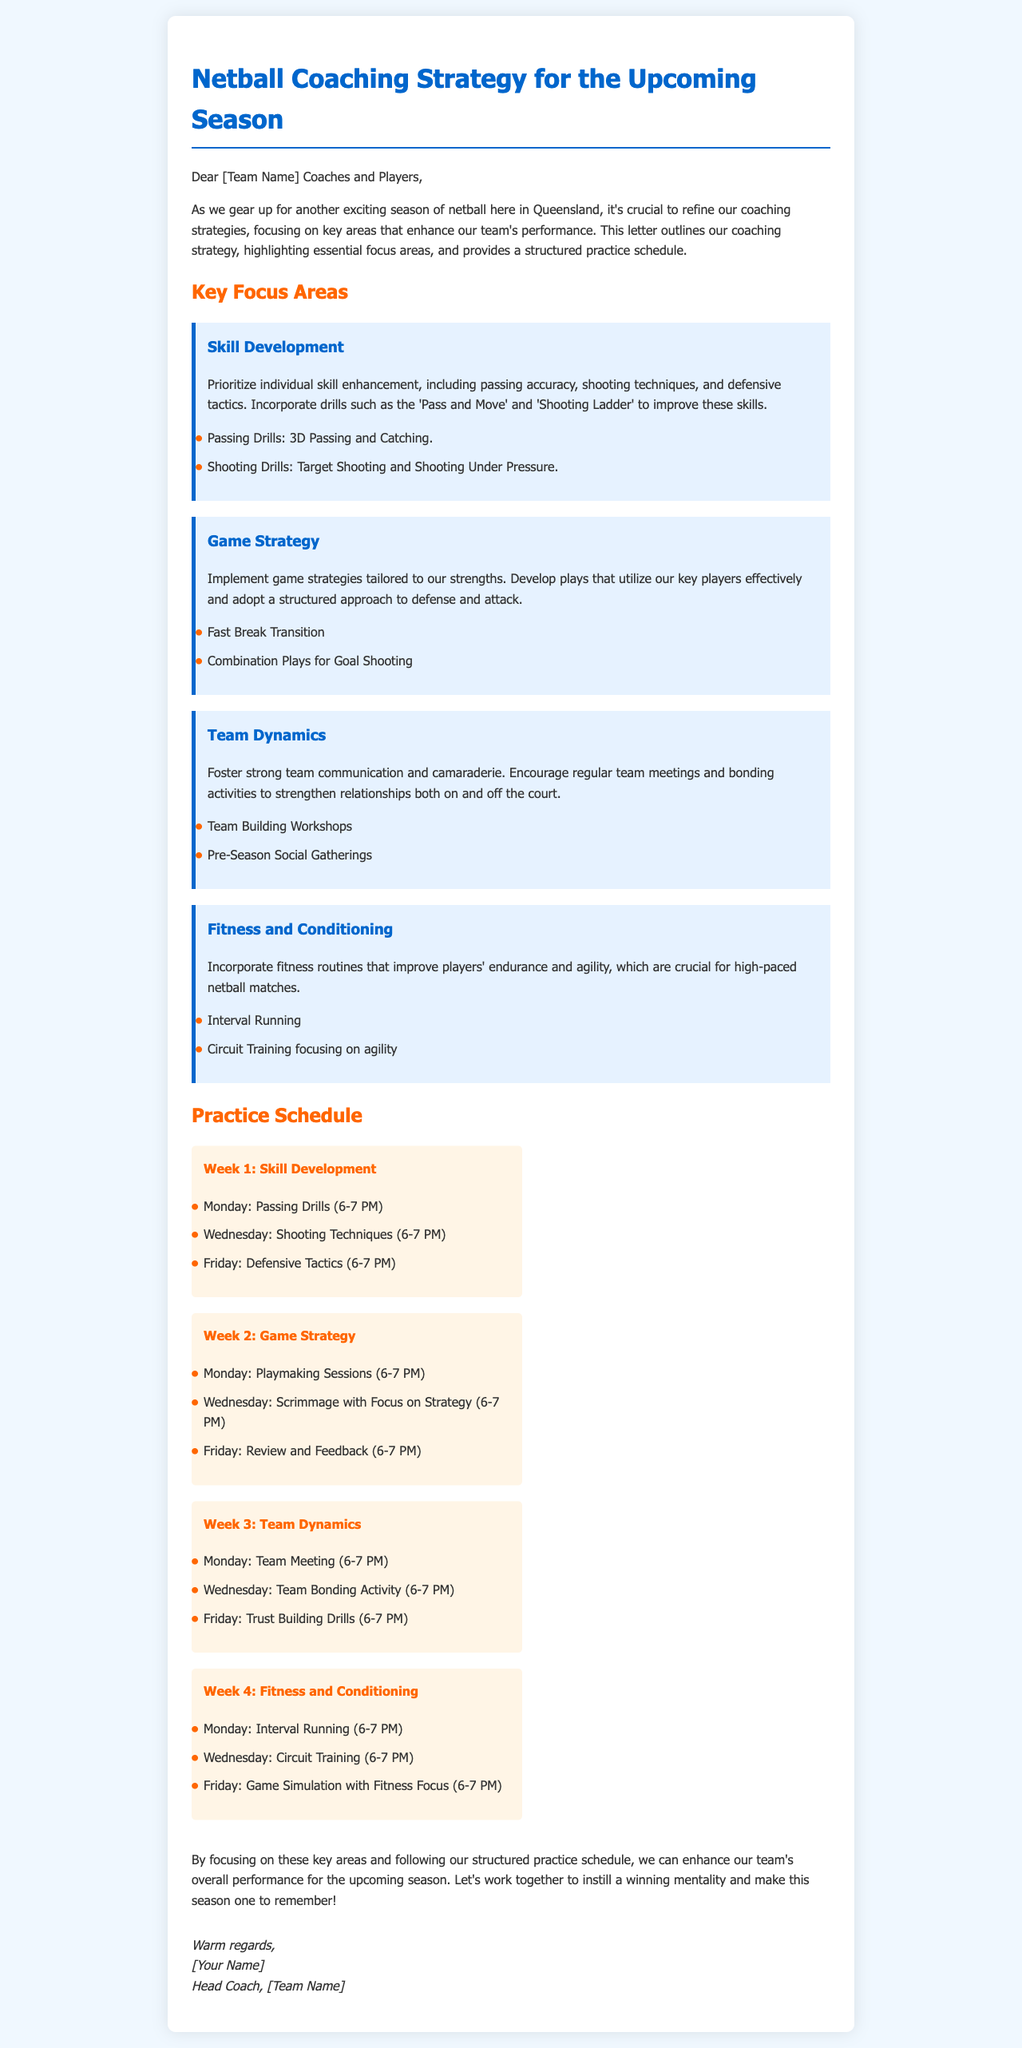What are the key focus areas? The letter outlines the key focus areas which are Skill Development, Game Strategy, Team Dynamics, and Fitness and Conditioning.
Answer: Skill Development, Game Strategy, Team Dynamics, Fitness and Conditioning When is the first practice session for Passing Drills? The document specifies that Passing Drills are scheduled for Monday of Week 1 from 6-7 PM.
Answer: Monday: 6-7 PM How often is the team meeting scheduled? The letter indicates that there is a team meeting scheduled for Monday of Week 3, which implies it is a once weekly occurrence during that focus area.
Answer: Once What is the main goal of this document? The primary purpose of the letter is to outline the coaching strategy for the upcoming season, focusing on key areas and a practice schedule.
Answer: Coaching strategy What is the focus of Week 2 practices? The practices in Week 2 aim to develop Game Strategy, in particular through plays and scrimmages.
Answer: Game Strategy Which drill is suggested for shooting under pressure? The letter specifies 'Shooting Under Pressure' as a drill to improve shooting skills.
Answer: Shooting Under Pressure What time are practice sessions generally scheduled? The practice sessions are consistently scheduled from 6-7 PM.
Answer: 6-7 PM What type of activities are included in Team Dynamics? The document mentions regular team meetings and bonding activities as part of Team Dynamics.
Answer: Team meetings and bonding activities 